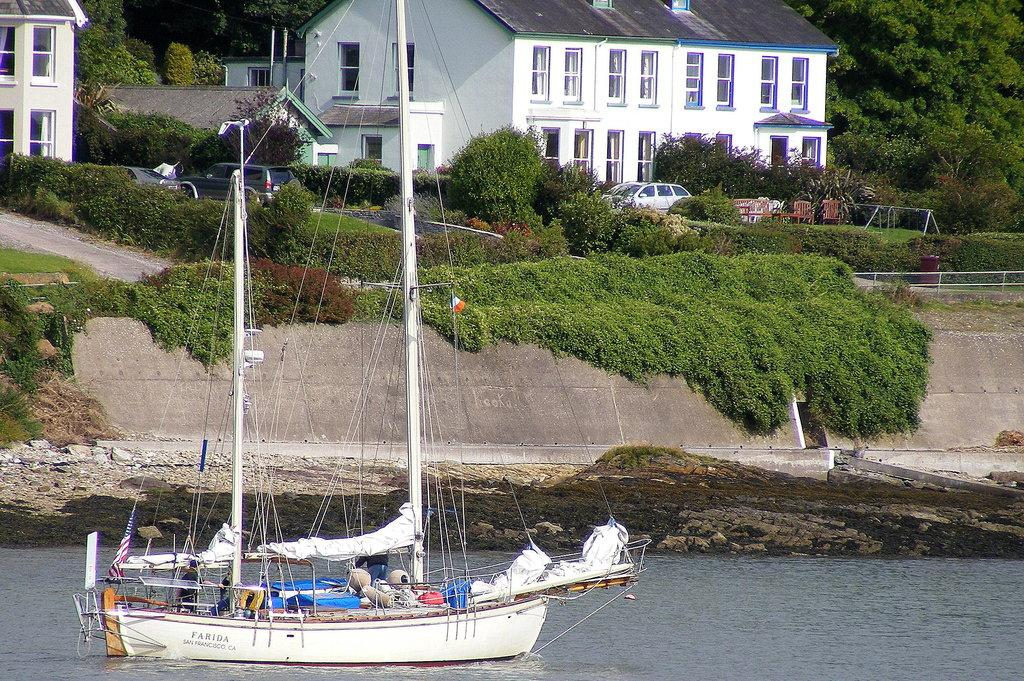What is located on the water at the bottom of the image? There is a boat on the water at the bottom of the image. What can be seen in the background of the image? Buildings, trees, plants, vehicles, chairs, and grass are present in the background of the image. What type of stick is the governor holding in the image? There is no stick or governor present in the image. 